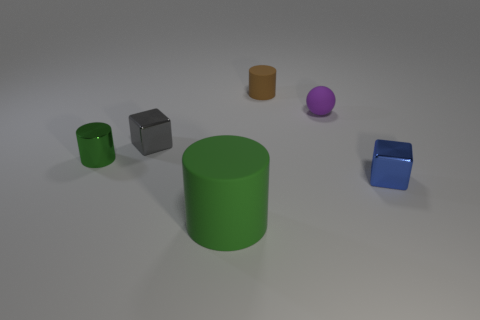What shape is the small blue thing that is in front of the tiny thing behind the purple thing behind the small green metal cylinder?
Provide a succinct answer. Cube. The small object that is made of the same material as the tiny purple ball is what color?
Make the answer very short. Brown. There is a small metal object that is in front of the shiny thing on the left side of the metal block left of the large thing; what color is it?
Offer a terse response. Blue. What number of cylinders are tiny things or tiny brown rubber things?
Your response must be concise. 2. There is a thing that is the same color as the metallic cylinder; what material is it?
Provide a short and direct response. Rubber. There is a small rubber cylinder; is it the same color as the small object right of the purple ball?
Give a very brief answer. No. What color is the small rubber cylinder?
Provide a succinct answer. Brown. How many things are rubber things or tiny cylinders?
Offer a very short reply. 4. There is a blue cube that is the same size as the matte ball; what material is it?
Your answer should be compact. Metal. What is the size of the matte cylinder that is behind the tiny ball?
Provide a succinct answer. Small. 